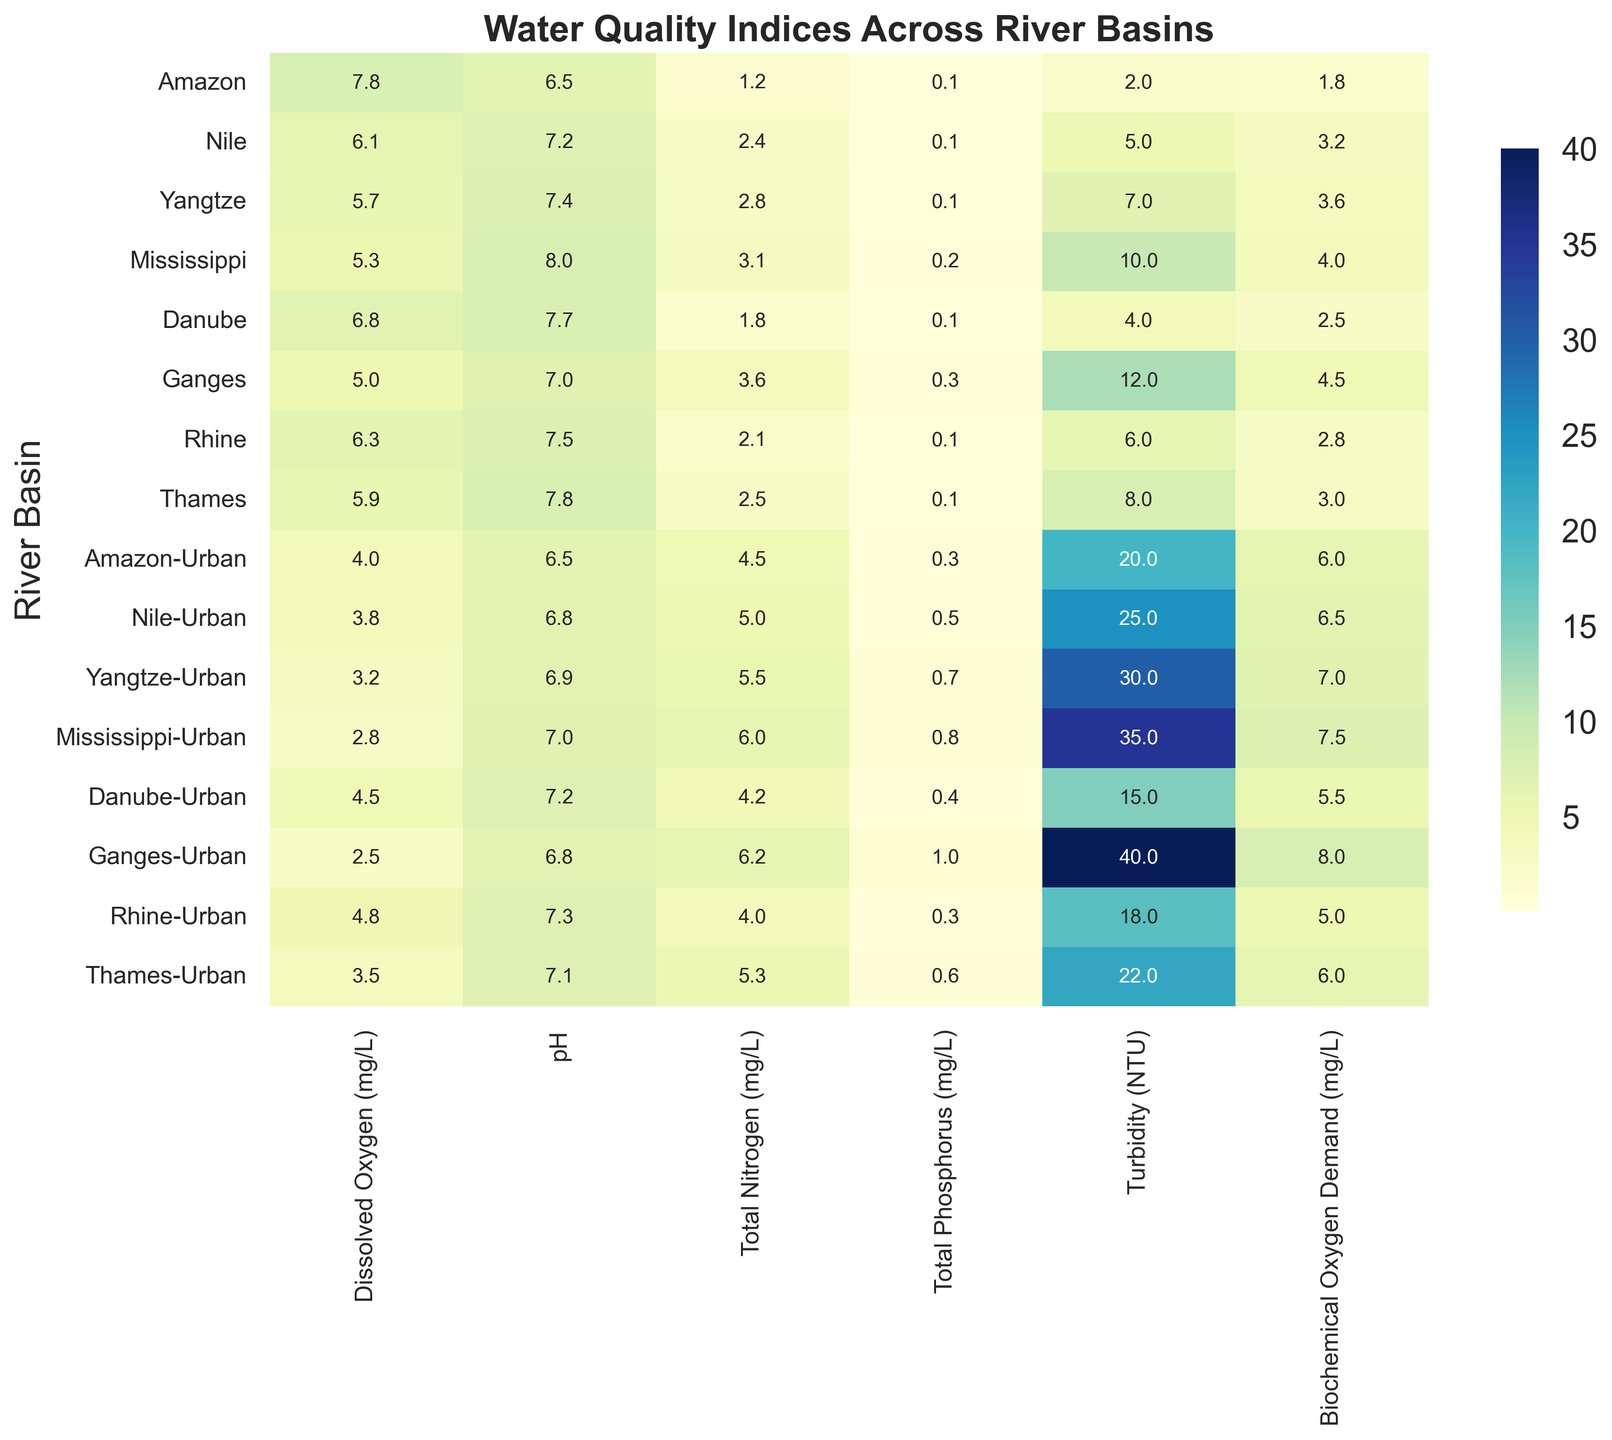What is the difference in Biochemical Oxygen Demand (BOD) between the Ganges River basin and the Ganges-Urban basin? First, find the Biochemical Oxygen Demand values for both basins: Ganges is 4.5 mg/L and Ganges-Urban is 8.0 mg/L. Then, subtract the BOD of the Ganges River basin from the BOD of the Ganges-Urban basin: 8.0 - 4.5 = 3.5 mg/L
Answer: 3.5 mg/L Which urban river basin has the highest Turbidity and what is its value? Look at the row corresponding to each urban river basin and identify the highest Turbidity value across these rows. The urban river basin with the highest Turbidity is Ganges-Urban with a value of 40 NTU
Answer: Ganges-Urban, 40 NTU How does the Dissolved Oxygen (DO) level in the Amazon basin compare to that in the Amazon-Urban basin? Find the Dissolved Oxygen values for the Amazon and Amazon-Urban basins: Amazon is 7.8 mg/L and Amazon-Urban is 4.0 mg/L. Compare the values to see that the DO level is higher in the Amazon basin than in the Amazon-Urban basin
Answer: Amazon basin > Amazon-Urban basin Which river basin has the lowest pH value and what does that imply about the water quality? Check the pH values in the heatmap and identify the lowest value, which is 6.5 for both Amazon and Amazon-Urban basins. Lower pH may indicate higher acidity, which can be harmful to aquatic life
Answer: Amazon and Amazon-Urban, 6.5 Calculate the average Total Nitrogen (TN) levels across all urban river basins. First, find the Total Nitrogen levels for all urban basins: 4.5, 5.0, 5.5, 6.0, 4.2, 6.2, 4.0, and 5.3 mg/L. Sum them: 4.5 + 5.0 + 5.5 + 6.0 + 4.2 + 6.2 + 4.0 + 5.3 = 40.7 mg/L. Then divide by the number of basins (8): 40.7 / 8 = 5.09 mg/L
Answer: 5.09 mg/L What trend can be observed in the Urbanization Level and its impact on Total Phosphorus across the river basins? Generally, as Urbanization Level increases, Total Phosphorus levels also increase. Comparing the columns for Urbanization Level and Total Phosphorus, urban basins show higher phosphorus levels compared to their non-urban counterparts
Answer: Higher urbanization increases Total Phosphorus Among the non-urban river basins, which has the highest Biochemical Oxygen Demand (BOD) and what is the numerical value? Look for the BOD values in the non-urban sections of the heatmap. The highest BOD among these is found in the Mississippi River basin with a value of 4.0 mg/L
Answer: Mississippi, 4.0 mg/L 